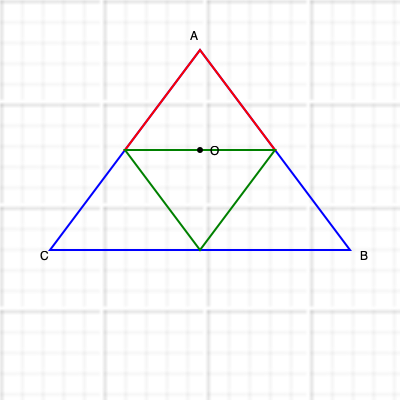In the geometric pattern shown above, which is commonly found in Islamic tile designs, triangle ABC is an equilateral triangle. If O is the center of the inscribed circle of triangle ABC, what is the ratio of the area of triangle ABO to the area of triangle ABC? Let's approach this step-by-step:

1) In an equilateral triangle, the center of the inscribed circle (O) is located at the intersection of the angle bisectors, which divide each angle into three equal parts.

2) This means that angle ABO is $\frac{1}{3}$ of angle ABC, which is 60° in an equilateral triangle.

3) So, angle ABO = $\frac{60°}{3} = 20°$

4) In triangle ABO:
   - AB is a side of the original equilateral triangle
   - BO is a radius of the inscribed circle, which bisects angle ABC
   - AO is also a radius of the inscribed circle

5) The area of a triangle is given by the formula: $Area = \frac{1}{2} \cdot base \cdot height$

6) For triangle ABC, the height is $\frac{\sqrt{3}}{2}$ times the side length.
   $Area_{ABC} = \frac{1}{2} \cdot AB \cdot \frac{\sqrt{3}}{2}AB = \frac{\sqrt{3}}{4}AB^2$

7) For triangle ABO, we can use the sine formula:
   $Area_{ABO} = \frac{1}{2} \cdot AB \cdot BO \cdot \sin(20°)$

8) The ratio of the areas is:
   $\frac{Area_{ABO}}{Area_{ABC}} = \frac{\frac{1}{2} \cdot AB \cdot BO \cdot \sin(20°)}{\frac{\sqrt{3}}{4}AB^2} = \frac{2BO \cdot \sin(20°)}{\sqrt{3}AB}$

9) In an equilateral triangle, $BO = \frac{AB}{\sqrt{3}}$

10) Substituting this:
    $\frac{Area_{ABO}}{Area_{ABC}} = \frac{2 \cdot \frac{AB}{\sqrt{3}} \cdot \sin(20°)}{\sqrt{3}AB} = \frac{2 \cdot \sin(20°)}{3} \approx 0.1111$

11) This is exactly $\frac{1}{9}$
Answer: $\frac{1}{9}$ 